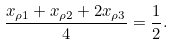Convert formula to latex. <formula><loc_0><loc_0><loc_500><loc_500>\frac { x _ { \rho 1 } + x _ { \rho 2 } + 2 x _ { \rho 3 } } { 4 } = \frac { 1 } { 2 } .</formula> 